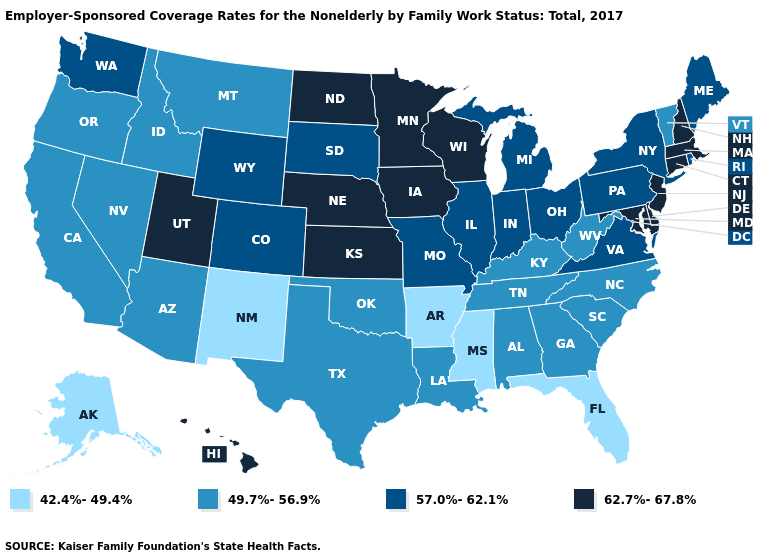Name the states that have a value in the range 49.7%-56.9%?
Write a very short answer. Alabama, Arizona, California, Georgia, Idaho, Kentucky, Louisiana, Montana, Nevada, North Carolina, Oklahoma, Oregon, South Carolina, Tennessee, Texas, Vermont, West Virginia. What is the lowest value in the USA?
Write a very short answer. 42.4%-49.4%. Does Vermont have the lowest value in the Northeast?
Answer briefly. Yes. Does Oregon have the same value as Washington?
Concise answer only. No. Does Wisconsin have the lowest value in the MidWest?
Write a very short answer. No. Among the states that border Pennsylvania , which have the lowest value?
Write a very short answer. West Virginia. Name the states that have a value in the range 49.7%-56.9%?
Answer briefly. Alabama, Arizona, California, Georgia, Idaho, Kentucky, Louisiana, Montana, Nevada, North Carolina, Oklahoma, Oregon, South Carolina, Tennessee, Texas, Vermont, West Virginia. Does South Dakota have a higher value than Illinois?
Short answer required. No. What is the value of Pennsylvania?
Answer briefly. 57.0%-62.1%. Among the states that border Oklahoma , does New Mexico have the lowest value?
Quick response, please. Yes. Among the states that border Tennessee , which have the highest value?
Keep it brief. Missouri, Virginia. What is the value of Michigan?
Keep it brief. 57.0%-62.1%. Does Washington have a lower value than Hawaii?
Write a very short answer. Yes. Does Illinois have the highest value in the USA?
Concise answer only. No. What is the value of Hawaii?
Concise answer only. 62.7%-67.8%. 